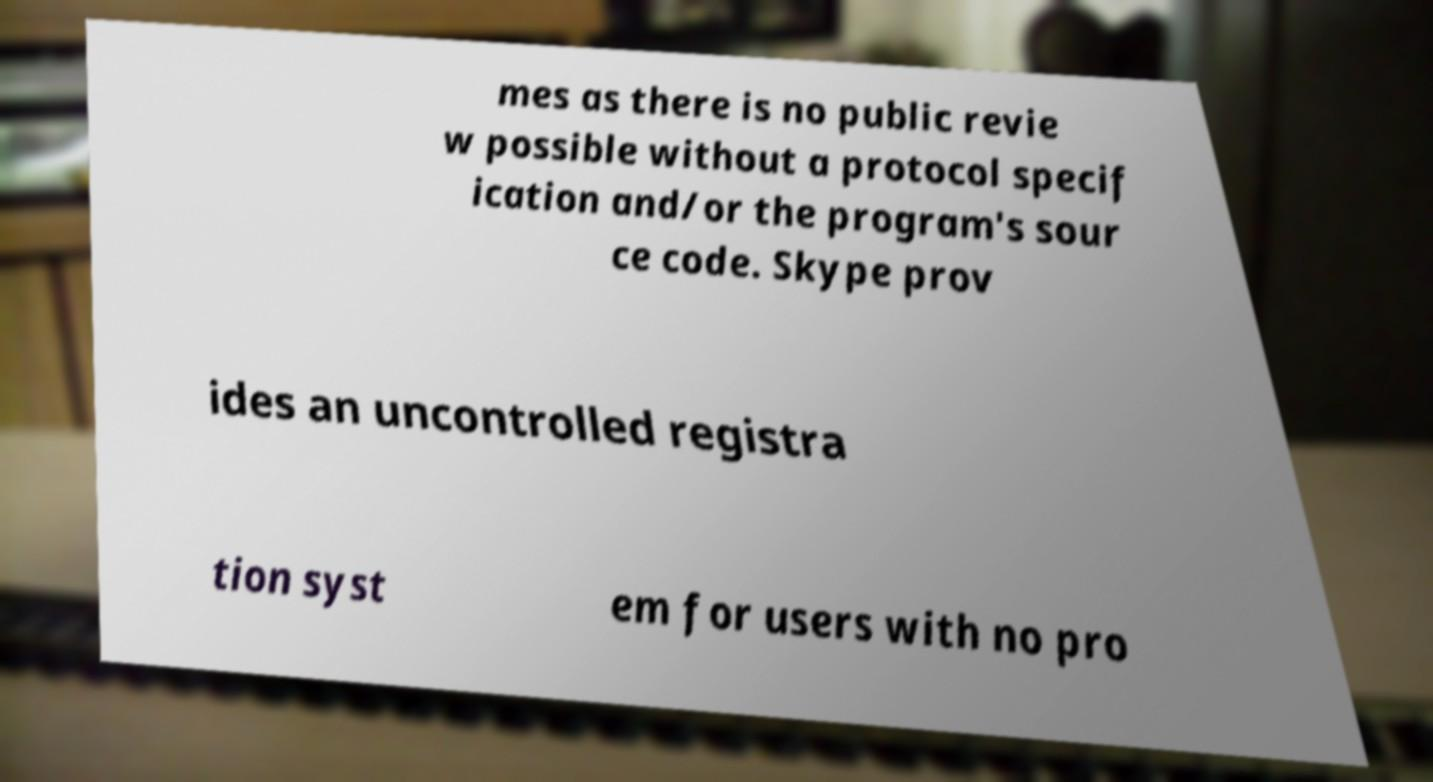Could you assist in decoding the text presented in this image and type it out clearly? mes as there is no public revie w possible without a protocol specif ication and/or the program's sour ce code. Skype prov ides an uncontrolled registra tion syst em for users with no pro 